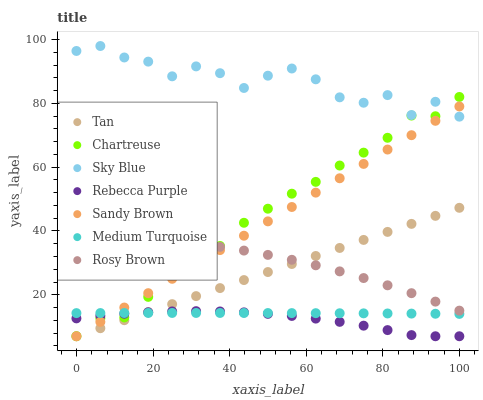Does Rebecca Purple have the minimum area under the curve?
Answer yes or no. Yes. Does Sky Blue have the maximum area under the curve?
Answer yes or no. Yes. Does Chartreuse have the minimum area under the curve?
Answer yes or no. No. Does Chartreuse have the maximum area under the curve?
Answer yes or no. No. Is Tan the smoothest?
Answer yes or no. Yes. Is Sky Blue the roughest?
Answer yes or no. Yes. Is Chartreuse the smoothest?
Answer yes or no. No. Is Chartreuse the roughest?
Answer yes or no. No. Does Chartreuse have the lowest value?
Answer yes or no. Yes. Does Medium Turquoise have the lowest value?
Answer yes or no. No. Does Sky Blue have the highest value?
Answer yes or no. Yes. Does Chartreuse have the highest value?
Answer yes or no. No. Is Rebecca Purple less than Sky Blue?
Answer yes or no. Yes. Is Sky Blue greater than Rebecca Purple?
Answer yes or no. Yes. Does Chartreuse intersect Sandy Brown?
Answer yes or no. Yes. Is Chartreuse less than Sandy Brown?
Answer yes or no. No. Is Chartreuse greater than Sandy Brown?
Answer yes or no. No. Does Rebecca Purple intersect Sky Blue?
Answer yes or no. No. 